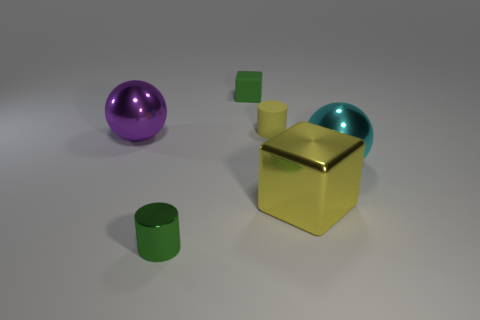How many things are metallic spheres that are on the left side of the tiny rubber cube or big metal spheres that are on the right side of the tiny cube?
Your answer should be very brief. 2. Is the size of the green metallic object the same as the yellow cylinder?
Offer a very short reply. Yes. There is a rubber thing in front of the small matte block; is its shape the same as the small green object that is in front of the large cyan object?
Your answer should be very brief. Yes. What is the size of the purple metal thing?
Ensure brevity in your answer.  Large. There is a cylinder on the left side of the cube left of the cylinder right of the green block; what is it made of?
Your response must be concise. Metal. What number of other objects are the same color as the matte cube?
Your response must be concise. 1. What number of brown objects are cylinders or big metallic blocks?
Your answer should be compact. 0. There is a yellow thing that is behind the big cyan ball; what material is it?
Your response must be concise. Rubber. Do the ball that is on the right side of the tiny green matte cube and the purple thing have the same material?
Offer a very short reply. Yes. The big yellow object is what shape?
Provide a succinct answer. Cube. 